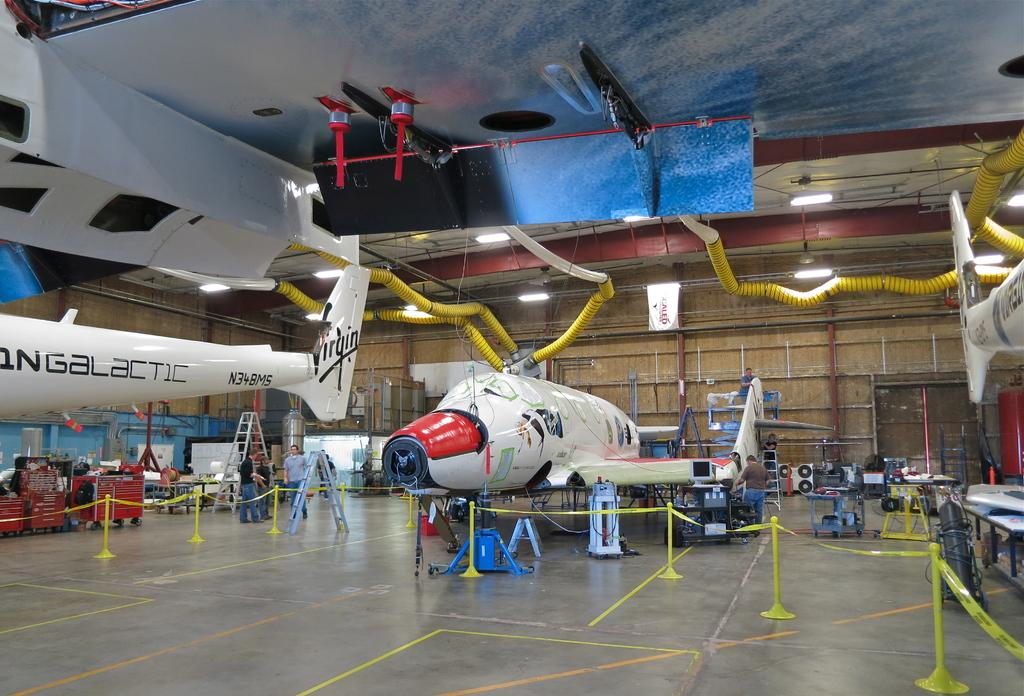Provide a one-sentence caption for the provided image. Large Galactic airplanes on display inside a building. 